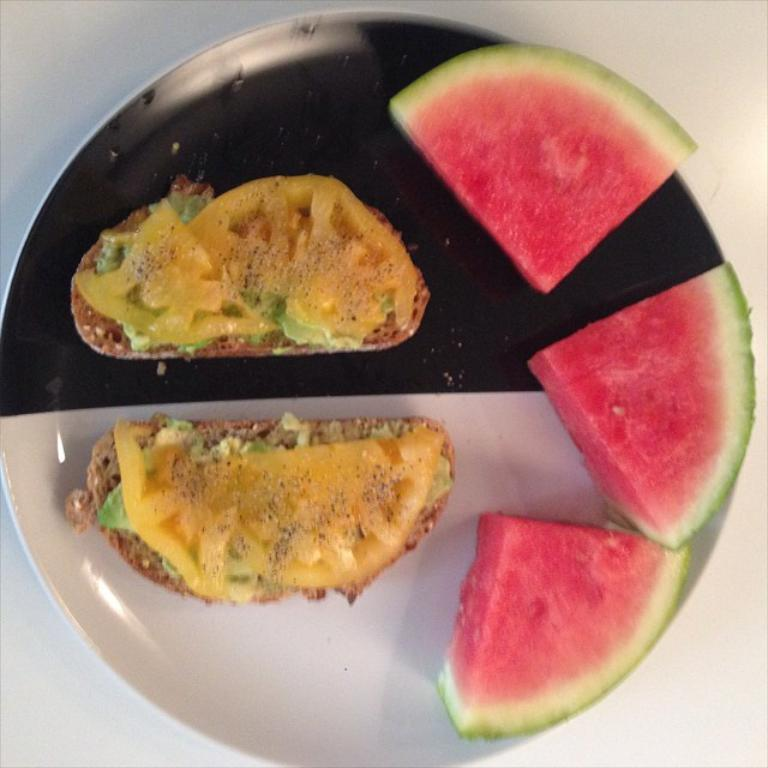What is the main object in the center of the image? There is a plate in the center of the image. What is on the plate? The plate contains watermelon slices and other food items. How does the plate increase in size throughout the image? The plate does not increase in size throughout the image; it remains the same size. 